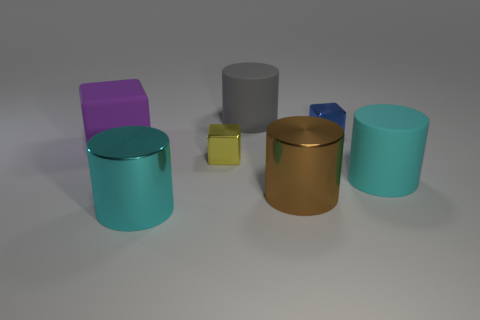Which cylinders in the image are closest to each other? The golden brown cylinder and the small yellow cube are the closest to each other. 